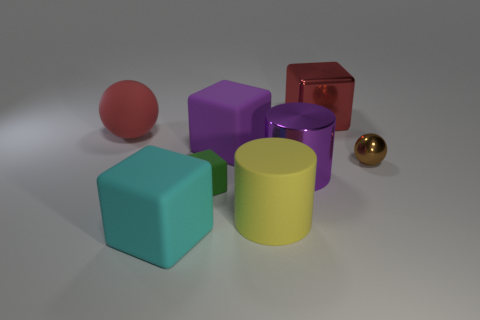Subtract all small green rubber blocks. How many blocks are left? 3 Subtract all brown spheres. How many spheres are left? 1 Add 1 small brown metal things. How many objects exist? 9 Subtract 1 blocks. How many blocks are left? 3 Subtract all purple balls. Subtract all yellow cylinders. How many balls are left? 2 Subtract all tiny red shiny objects. Subtract all tiny green cubes. How many objects are left? 7 Add 5 large yellow rubber cylinders. How many large yellow rubber cylinders are left? 6 Add 4 red things. How many red things exist? 6 Subtract 0 gray balls. How many objects are left? 8 Subtract all spheres. How many objects are left? 6 